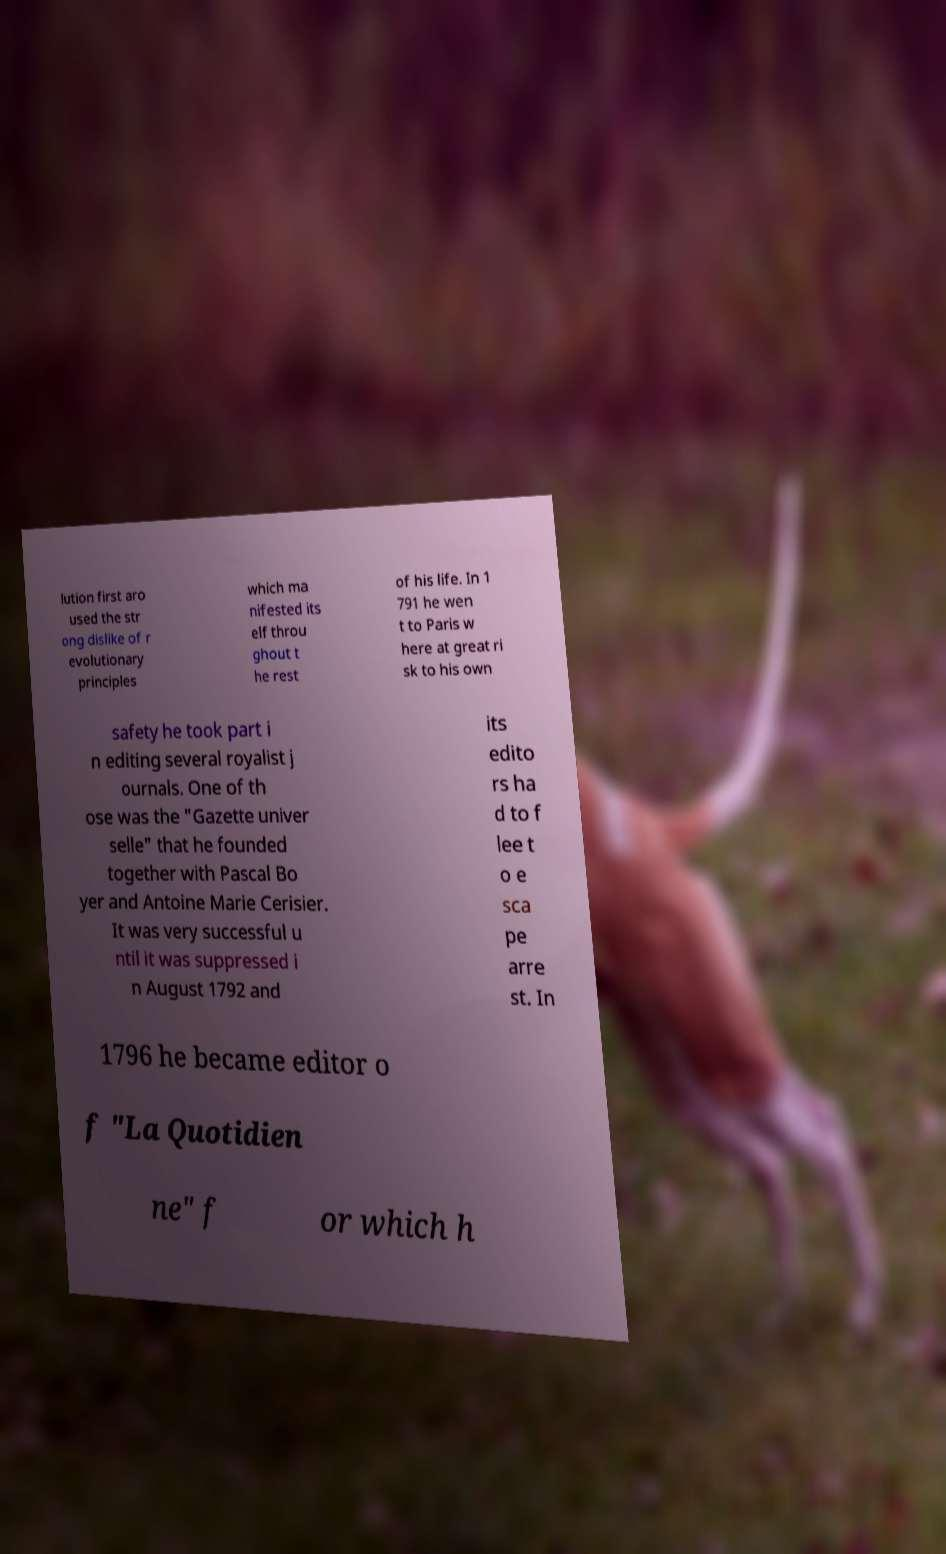Can you accurately transcribe the text from the provided image for me? lution first aro used the str ong dislike of r evolutionary principles which ma nifested its elf throu ghout t he rest of his life. In 1 791 he wen t to Paris w here at great ri sk to his own safety he took part i n editing several royalist j ournals. One of th ose was the "Gazette univer selle" that he founded together with Pascal Bo yer and Antoine Marie Cerisier. It was very successful u ntil it was suppressed i n August 1792 and its edito rs ha d to f lee t o e sca pe arre st. In 1796 he became editor o f "La Quotidien ne" f or which h 